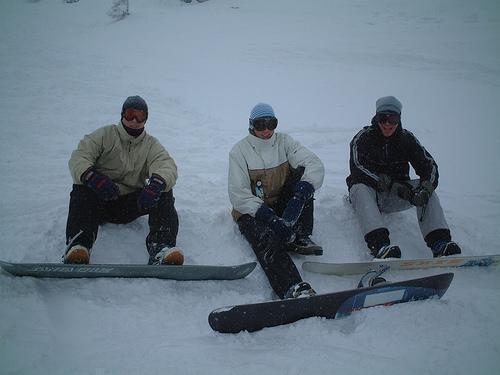Sitting like this allows the snowboarders to avoid doing what with their Snow boards?
Answer the question by selecting the correct answer among the 4 following choices.
Options: Losing them, selling them, scratching them, removing them. Removing them. 